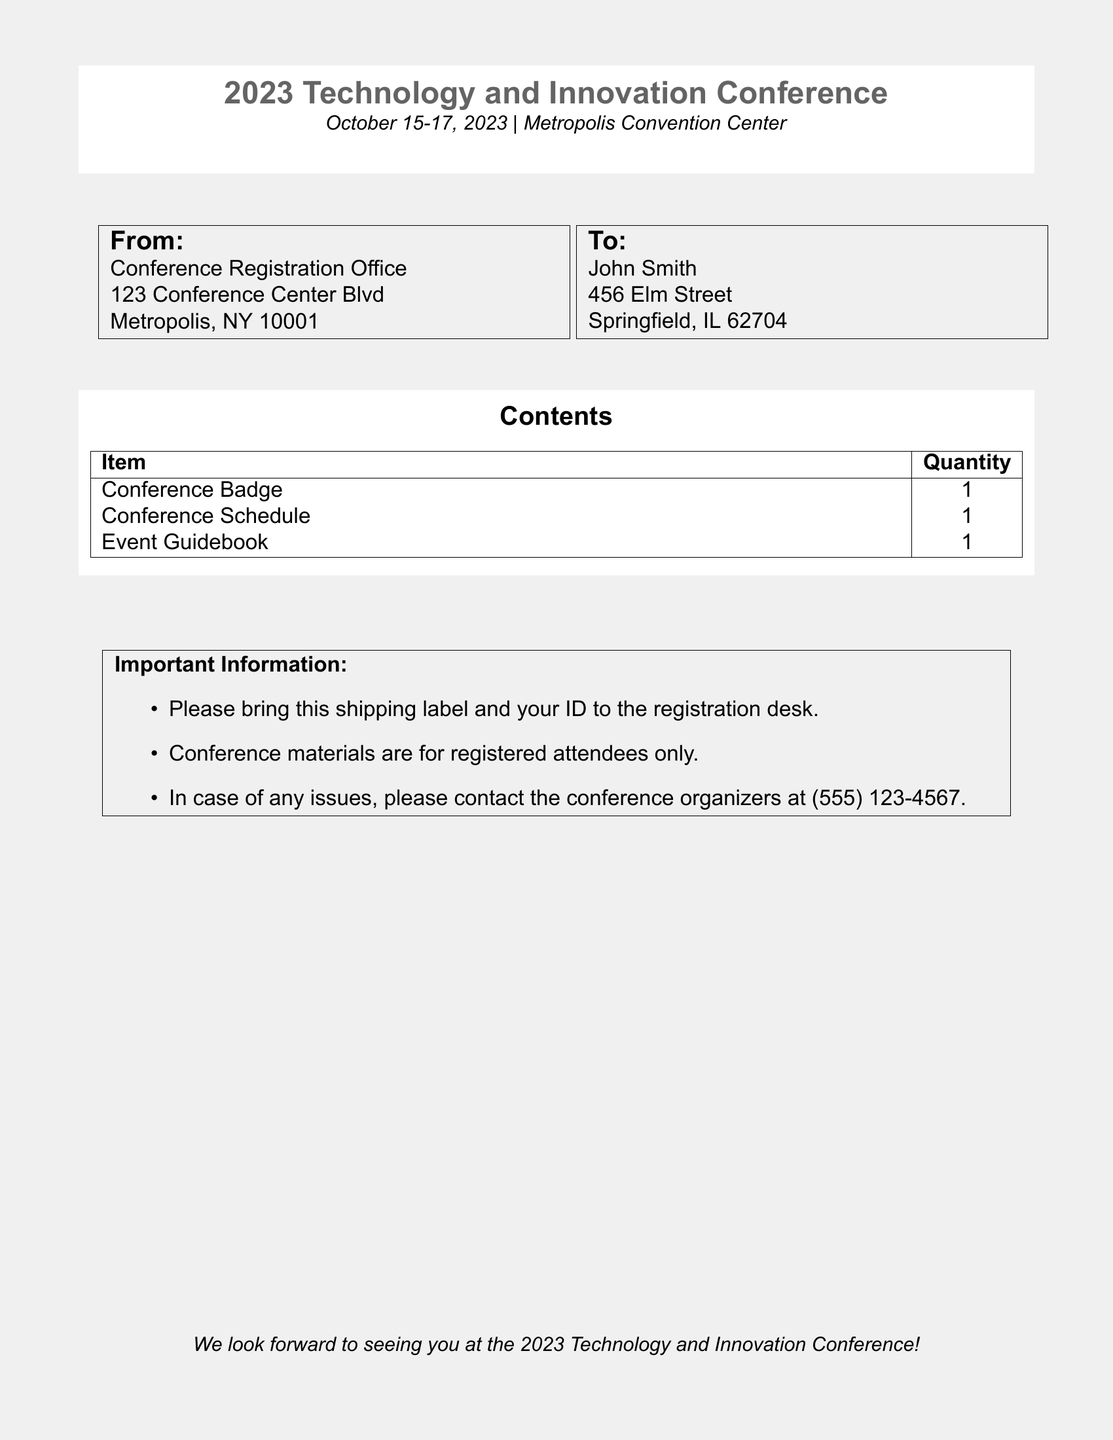what is the event name? The event name is stated prominently at the top of the document.
Answer: 2023 Technology and Innovation Conference when is the conference date? The conference date is included in the event timing.
Answer: October 15-17, 2023 where is the conference location? The location is mentioned in the header section of the document.
Answer: Metropolis Convention Center who is the recipient of the shipping label? The recipient's name is noted in the "To:" section of the document.
Answer: John Smith what is the quantity of conference badges included? The quantity is indicated in the "Contents" table of the document.
Answer: 1 what should you bring to the registration desk? The instructions specify items to bring to the registration desk.
Answer: this shipping label and your ID how can you contact the conference organizers? The document provides a specific contact number for inquiries.
Answer: (555) 123-4567 is the conference materials available for everyone? The document explicitly states the availability of materials for attendees.
Answer: no what items are included in the contents? The items are listed in a table under the "Contents" section.
Answer: Conference Badge, Conference Schedule, Event Guidebook 